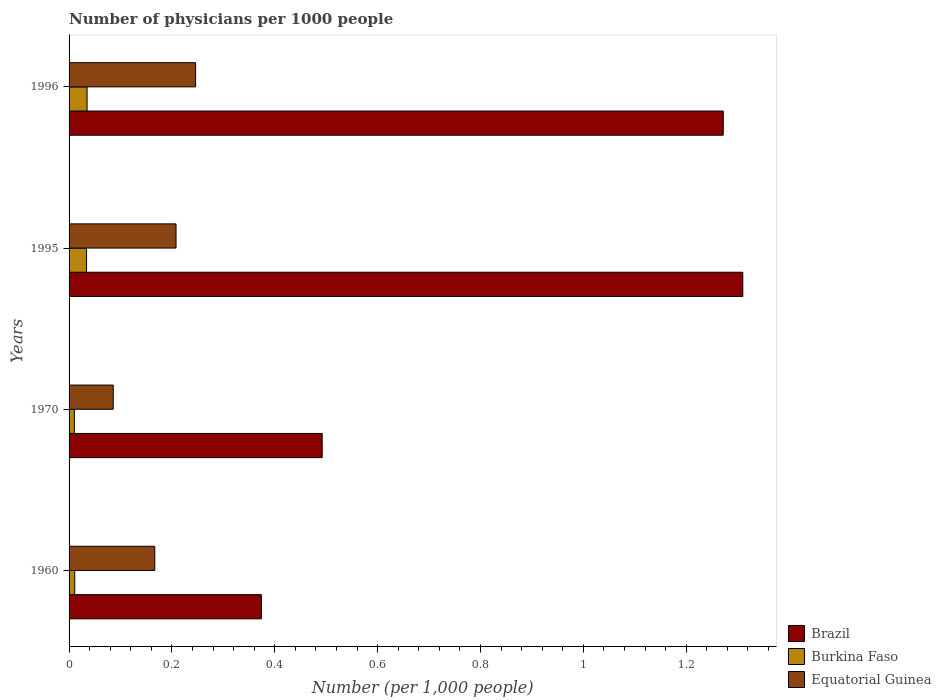How many different coloured bars are there?
Offer a very short reply. 3. How many groups of bars are there?
Provide a short and direct response. 4. Are the number of bars per tick equal to the number of legend labels?
Your response must be concise. Yes. How many bars are there on the 1st tick from the top?
Offer a very short reply. 3. In how many cases, is the number of bars for a given year not equal to the number of legend labels?
Your answer should be very brief. 0. What is the number of physicians in Burkina Faso in 1970?
Your answer should be compact. 0.01. Across all years, what is the maximum number of physicians in Burkina Faso?
Your response must be concise. 0.04. Across all years, what is the minimum number of physicians in Brazil?
Make the answer very short. 0.37. What is the total number of physicians in Burkina Faso in the graph?
Your response must be concise. 0.09. What is the difference between the number of physicians in Brazil in 1970 and that in 1995?
Make the answer very short. -0.82. What is the difference between the number of physicians in Equatorial Guinea in 1996 and the number of physicians in Brazil in 1960?
Give a very brief answer. -0.13. What is the average number of physicians in Burkina Faso per year?
Ensure brevity in your answer.  0.02. In the year 1995, what is the difference between the number of physicians in Equatorial Guinea and number of physicians in Brazil?
Your answer should be very brief. -1.1. In how many years, is the number of physicians in Brazil greater than 0.7200000000000001 ?
Offer a very short reply. 2. What is the ratio of the number of physicians in Equatorial Guinea in 1960 to that in 1995?
Make the answer very short. 0.8. What is the difference between the highest and the second highest number of physicians in Burkina Faso?
Offer a terse response. 0. What is the difference between the highest and the lowest number of physicians in Burkina Faso?
Make the answer very short. 0.02. What does the 1st bar from the top in 1996 represents?
Offer a very short reply. Equatorial Guinea. What does the 3rd bar from the bottom in 1960 represents?
Keep it short and to the point. Equatorial Guinea. How many bars are there?
Offer a terse response. 12. Are all the bars in the graph horizontal?
Provide a succinct answer. Yes. How many years are there in the graph?
Offer a terse response. 4. What is the difference between two consecutive major ticks on the X-axis?
Provide a short and direct response. 0.2. Does the graph contain grids?
Offer a terse response. No. What is the title of the graph?
Your answer should be compact. Number of physicians per 1000 people. Does "Other small states" appear as one of the legend labels in the graph?
Provide a short and direct response. No. What is the label or title of the X-axis?
Provide a short and direct response. Number (per 1,0 people). What is the Number (per 1,000 people) of Brazil in 1960?
Provide a short and direct response. 0.37. What is the Number (per 1,000 people) in Burkina Faso in 1960?
Give a very brief answer. 0.01. What is the Number (per 1,000 people) in Equatorial Guinea in 1960?
Your answer should be compact. 0.17. What is the Number (per 1,000 people) of Brazil in 1970?
Provide a short and direct response. 0.49. What is the Number (per 1,000 people) of Burkina Faso in 1970?
Offer a very short reply. 0.01. What is the Number (per 1,000 people) in Equatorial Guinea in 1970?
Offer a terse response. 0.09. What is the Number (per 1,000 people) in Brazil in 1995?
Your answer should be compact. 1.31. What is the Number (per 1,000 people) in Burkina Faso in 1995?
Your answer should be very brief. 0.03. What is the Number (per 1,000 people) in Equatorial Guinea in 1995?
Ensure brevity in your answer.  0.21. What is the Number (per 1,000 people) in Brazil in 1996?
Ensure brevity in your answer.  1.27. What is the Number (per 1,000 people) in Burkina Faso in 1996?
Give a very brief answer. 0.04. What is the Number (per 1,000 people) in Equatorial Guinea in 1996?
Offer a terse response. 0.25. Across all years, what is the maximum Number (per 1,000 people) of Brazil?
Your answer should be compact. 1.31. Across all years, what is the maximum Number (per 1,000 people) of Burkina Faso?
Offer a very short reply. 0.04. Across all years, what is the maximum Number (per 1,000 people) of Equatorial Guinea?
Provide a succinct answer. 0.25. Across all years, what is the minimum Number (per 1,000 people) of Brazil?
Keep it short and to the point. 0.37. Across all years, what is the minimum Number (per 1,000 people) in Burkina Faso?
Keep it short and to the point. 0.01. Across all years, what is the minimum Number (per 1,000 people) of Equatorial Guinea?
Make the answer very short. 0.09. What is the total Number (per 1,000 people) in Brazil in the graph?
Your answer should be very brief. 3.45. What is the total Number (per 1,000 people) of Burkina Faso in the graph?
Offer a terse response. 0.09. What is the total Number (per 1,000 people) in Equatorial Guinea in the graph?
Provide a short and direct response. 0.71. What is the difference between the Number (per 1,000 people) in Brazil in 1960 and that in 1970?
Your answer should be compact. -0.12. What is the difference between the Number (per 1,000 people) of Burkina Faso in 1960 and that in 1970?
Offer a very short reply. 0. What is the difference between the Number (per 1,000 people) in Equatorial Guinea in 1960 and that in 1970?
Give a very brief answer. 0.08. What is the difference between the Number (per 1,000 people) of Brazil in 1960 and that in 1995?
Offer a terse response. -0.94. What is the difference between the Number (per 1,000 people) of Burkina Faso in 1960 and that in 1995?
Your response must be concise. -0.02. What is the difference between the Number (per 1,000 people) in Equatorial Guinea in 1960 and that in 1995?
Keep it short and to the point. -0.04. What is the difference between the Number (per 1,000 people) in Brazil in 1960 and that in 1996?
Give a very brief answer. -0.9. What is the difference between the Number (per 1,000 people) in Burkina Faso in 1960 and that in 1996?
Make the answer very short. -0.02. What is the difference between the Number (per 1,000 people) in Equatorial Guinea in 1960 and that in 1996?
Provide a short and direct response. -0.08. What is the difference between the Number (per 1,000 people) of Brazil in 1970 and that in 1995?
Your response must be concise. -0.82. What is the difference between the Number (per 1,000 people) in Burkina Faso in 1970 and that in 1995?
Provide a short and direct response. -0.02. What is the difference between the Number (per 1,000 people) of Equatorial Guinea in 1970 and that in 1995?
Your response must be concise. -0.12. What is the difference between the Number (per 1,000 people) in Brazil in 1970 and that in 1996?
Give a very brief answer. -0.78. What is the difference between the Number (per 1,000 people) of Burkina Faso in 1970 and that in 1996?
Make the answer very short. -0.02. What is the difference between the Number (per 1,000 people) of Equatorial Guinea in 1970 and that in 1996?
Offer a terse response. -0.16. What is the difference between the Number (per 1,000 people) of Brazil in 1995 and that in 1996?
Offer a very short reply. 0.04. What is the difference between the Number (per 1,000 people) of Burkina Faso in 1995 and that in 1996?
Your answer should be compact. -0. What is the difference between the Number (per 1,000 people) in Equatorial Guinea in 1995 and that in 1996?
Your response must be concise. -0.04. What is the difference between the Number (per 1,000 people) in Brazil in 1960 and the Number (per 1,000 people) in Burkina Faso in 1970?
Keep it short and to the point. 0.36. What is the difference between the Number (per 1,000 people) in Brazil in 1960 and the Number (per 1,000 people) in Equatorial Guinea in 1970?
Ensure brevity in your answer.  0.29. What is the difference between the Number (per 1,000 people) of Burkina Faso in 1960 and the Number (per 1,000 people) of Equatorial Guinea in 1970?
Provide a succinct answer. -0.07. What is the difference between the Number (per 1,000 people) in Brazil in 1960 and the Number (per 1,000 people) in Burkina Faso in 1995?
Make the answer very short. 0.34. What is the difference between the Number (per 1,000 people) in Brazil in 1960 and the Number (per 1,000 people) in Equatorial Guinea in 1995?
Keep it short and to the point. 0.17. What is the difference between the Number (per 1,000 people) of Burkina Faso in 1960 and the Number (per 1,000 people) of Equatorial Guinea in 1995?
Provide a short and direct response. -0.2. What is the difference between the Number (per 1,000 people) in Brazil in 1960 and the Number (per 1,000 people) in Burkina Faso in 1996?
Offer a terse response. 0.34. What is the difference between the Number (per 1,000 people) in Brazil in 1960 and the Number (per 1,000 people) in Equatorial Guinea in 1996?
Offer a very short reply. 0.13. What is the difference between the Number (per 1,000 people) of Burkina Faso in 1960 and the Number (per 1,000 people) of Equatorial Guinea in 1996?
Your response must be concise. -0.23. What is the difference between the Number (per 1,000 people) of Brazil in 1970 and the Number (per 1,000 people) of Burkina Faso in 1995?
Your answer should be very brief. 0.46. What is the difference between the Number (per 1,000 people) of Brazil in 1970 and the Number (per 1,000 people) of Equatorial Guinea in 1995?
Ensure brevity in your answer.  0.28. What is the difference between the Number (per 1,000 people) of Burkina Faso in 1970 and the Number (per 1,000 people) of Equatorial Guinea in 1995?
Your answer should be compact. -0.2. What is the difference between the Number (per 1,000 people) of Brazil in 1970 and the Number (per 1,000 people) of Burkina Faso in 1996?
Offer a very short reply. 0.46. What is the difference between the Number (per 1,000 people) of Brazil in 1970 and the Number (per 1,000 people) of Equatorial Guinea in 1996?
Ensure brevity in your answer.  0.25. What is the difference between the Number (per 1,000 people) of Burkina Faso in 1970 and the Number (per 1,000 people) of Equatorial Guinea in 1996?
Provide a succinct answer. -0.24. What is the difference between the Number (per 1,000 people) of Brazil in 1995 and the Number (per 1,000 people) of Burkina Faso in 1996?
Offer a terse response. 1.27. What is the difference between the Number (per 1,000 people) in Brazil in 1995 and the Number (per 1,000 people) in Equatorial Guinea in 1996?
Ensure brevity in your answer.  1.06. What is the difference between the Number (per 1,000 people) of Burkina Faso in 1995 and the Number (per 1,000 people) of Equatorial Guinea in 1996?
Your answer should be compact. -0.21. What is the average Number (per 1,000 people) in Brazil per year?
Provide a short and direct response. 0.86. What is the average Number (per 1,000 people) in Burkina Faso per year?
Ensure brevity in your answer.  0.02. What is the average Number (per 1,000 people) of Equatorial Guinea per year?
Offer a terse response. 0.18. In the year 1960, what is the difference between the Number (per 1,000 people) in Brazil and Number (per 1,000 people) in Burkina Faso?
Your response must be concise. 0.36. In the year 1960, what is the difference between the Number (per 1,000 people) in Brazil and Number (per 1,000 people) in Equatorial Guinea?
Offer a terse response. 0.21. In the year 1960, what is the difference between the Number (per 1,000 people) of Burkina Faso and Number (per 1,000 people) of Equatorial Guinea?
Keep it short and to the point. -0.16. In the year 1970, what is the difference between the Number (per 1,000 people) in Brazil and Number (per 1,000 people) in Burkina Faso?
Give a very brief answer. 0.48. In the year 1970, what is the difference between the Number (per 1,000 people) of Brazil and Number (per 1,000 people) of Equatorial Guinea?
Give a very brief answer. 0.41. In the year 1970, what is the difference between the Number (per 1,000 people) of Burkina Faso and Number (per 1,000 people) of Equatorial Guinea?
Ensure brevity in your answer.  -0.08. In the year 1995, what is the difference between the Number (per 1,000 people) of Brazil and Number (per 1,000 people) of Burkina Faso?
Your response must be concise. 1.28. In the year 1995, what is the difference between the Number (per 1,000 people) in Brazil and Number (per 1,000 people) in Equatorial Guinea?
Provide a short and direct response. 1.1. In the year 1995, what is the difference between the Number (per 1,000 people) of Burkina Faso and Number (per 1,000 people) of Equatorial Guinea?
Provide a short and direct response. -0.17. In the year 1996, what is the difference between the Number (per 1,000 people) of Brazil and Number (per 1,000 people) of Burkina Faso?
Ensure brevity in your answer.  1.24. In the year 1996, what is the difference between the Number (per 1,000 people) in Brazil and Number (per 1,000 people) in Equatorial Guinea?
Keep it short and to the point. 1.03. In the year 1996, what is the difference between the Number (per 1,000 people) of Burkina Faso and Number (per 1,000 people) of Equatorial Guinea?
Give a very brief answer. -0.21. What is the ratio of the Number (per 1,000 people) of Brazil in 1960 to that in 1970?
Keep it short and to the point. 0.76. What is the ratio of the Number (per 1,000 people) in Burkina Faso in 1960 to that in 1970?
Offer a very short reply. 1.07. What is the ratio of the Number (per 1,000 people) of Equatorial Guinea in 1960 to that in 1970?
Make the answer very short. 1.94. What is the ratio of the Number (per 1,000 people) in Brazil in 1960 to that in 1995?
Offer a terse response. 0.29. What is the ratio of the Number (per 1,000 people) in Burkina Faso in 1960 to that in 1995?
Ensure brevity in your answer.  0.32. What is the ratio of the Number (per 1,000 people) in Equatorial Guinea in 1960 to that in 1995?
Offer a very short reply. 0.8. What is the ratio of the Number (per 1,000 people) in Brazil in 1960 to that in 1996?
Provide a succinct answer. 0.29. What is the ratio of the Number (per 1,000 people) of Burkina Faso in 1960 to that in 1996?
Your answer should be compact. 0.31. What is the ratio of the Number (per 1,000 people) in Equatorial Guinea in 1960 to that in 1996?
Offer a very short reply. 0.68. What is the ratio of the Number (per 1,000 people) of Brazil in 1970 to that in 1995?
Make the answer very short. 0.38. What is the ratio of the Number (per 1,000 people) in Burkina Faso in 1970 to that in 1995?
Provide a short and direct response. 0.3. What is the ratio of the Number (per 1,000 people) of Equatorial Guinea in 1970 to that in 1995?
Your response must be concise. 0.41. What is the ratio of the Number (per 1,000 people) of Brazil in 1970 to that in 1996?
Offer a very short reply. 0.39. What is the ratio of the Number (per 1,000 people) of Burkina Faso in 1970 to that in 1996?
Your answer should be compact. 0.29. What is the ratio of the Number (per 1,000 people) of Equatorial Guinea in 1970 to that in 1996?
Give a very brief answer. 0.35. What is the ratio of the Number (per 1,000 people) in Brazil in 1995 to that in 1996?
Your answer should be compact. 1.03. What is the ratio of the Number (per 1,000 people) of Burkina Faso in 1995 to that in 1996?
Your answer should be very brief. 0.97. What is the ratio of the Number (per 1,000 people) in Equatorial Guinea in 1995 to that in 1996?
Make the answer very short. 0.85. What is the difference between the highest and the second highest Number (per 1,000 people) in Brazil?
Ensure brevity in your answer.  0.04. What is the difference between the highest and the second highest Number (per 1,000 people) of Equatorial Guinea?
Your answer should be compact. 0.04. What is the difference between the highest and the lowest Number (per 1,000 people) of Brazil?
Make the answer very short. 0.94. What is the difference between the highest and the lowest Number (per 1,000 people) in Burkina Faso?
Keep it short and to the point. 0.02. What is the difference between the highest and the lowest Number (per 1,000 people) of Equatorial Guinea?
Provide a short and direct response. 0.16. 